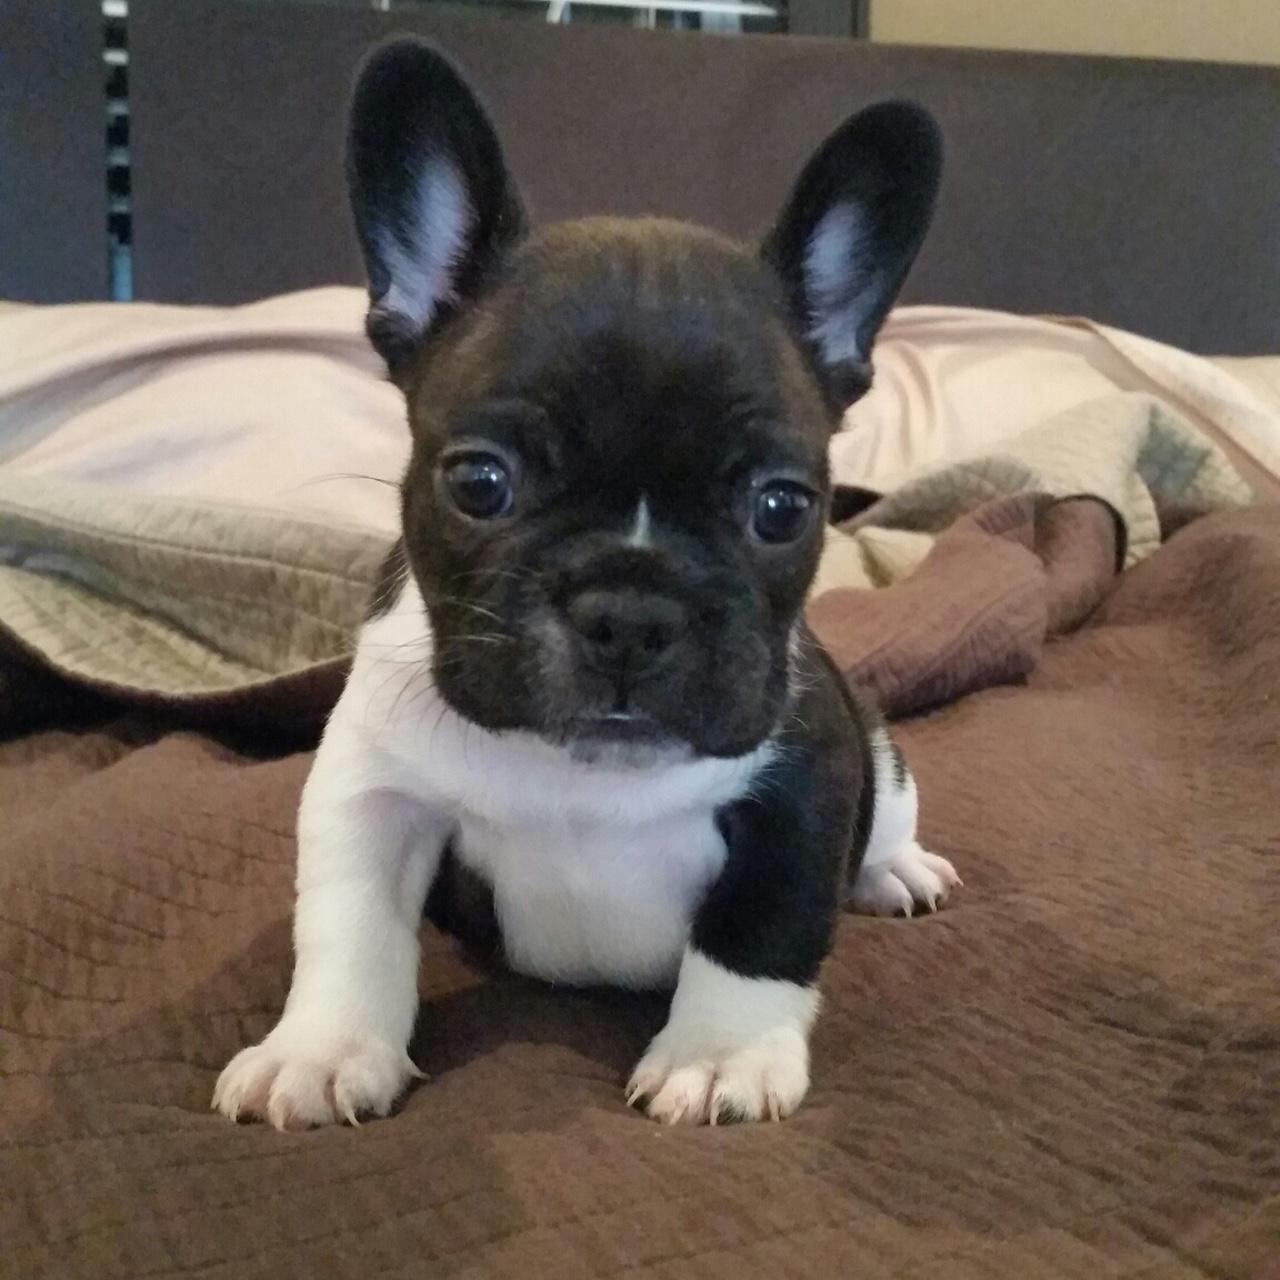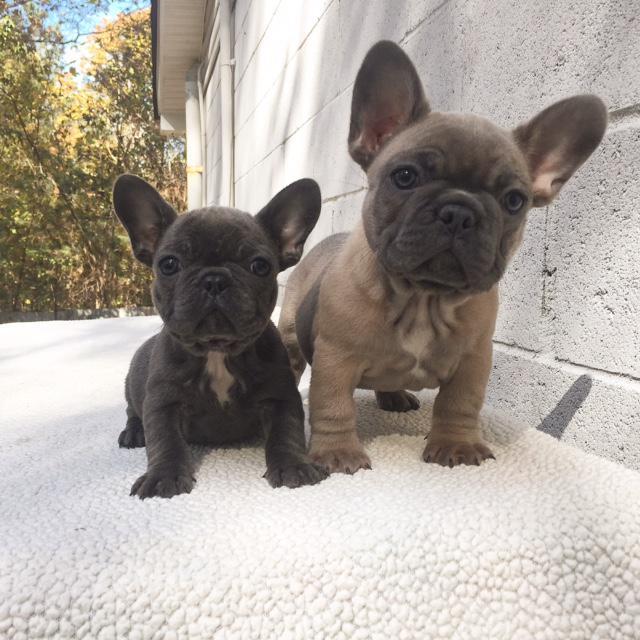The first image is the image on the left, the second image is the image on the right. Considering the images on both sides, is "There are exactly three puppies." valid? Answer yes or no. Yes. The first image is the image on the left, the second image is the image on the right. Examine the images to the left and right. Is the description "A total of three puppies are shown, most of them sitting." accurate? Answer yes or no. Yes. 